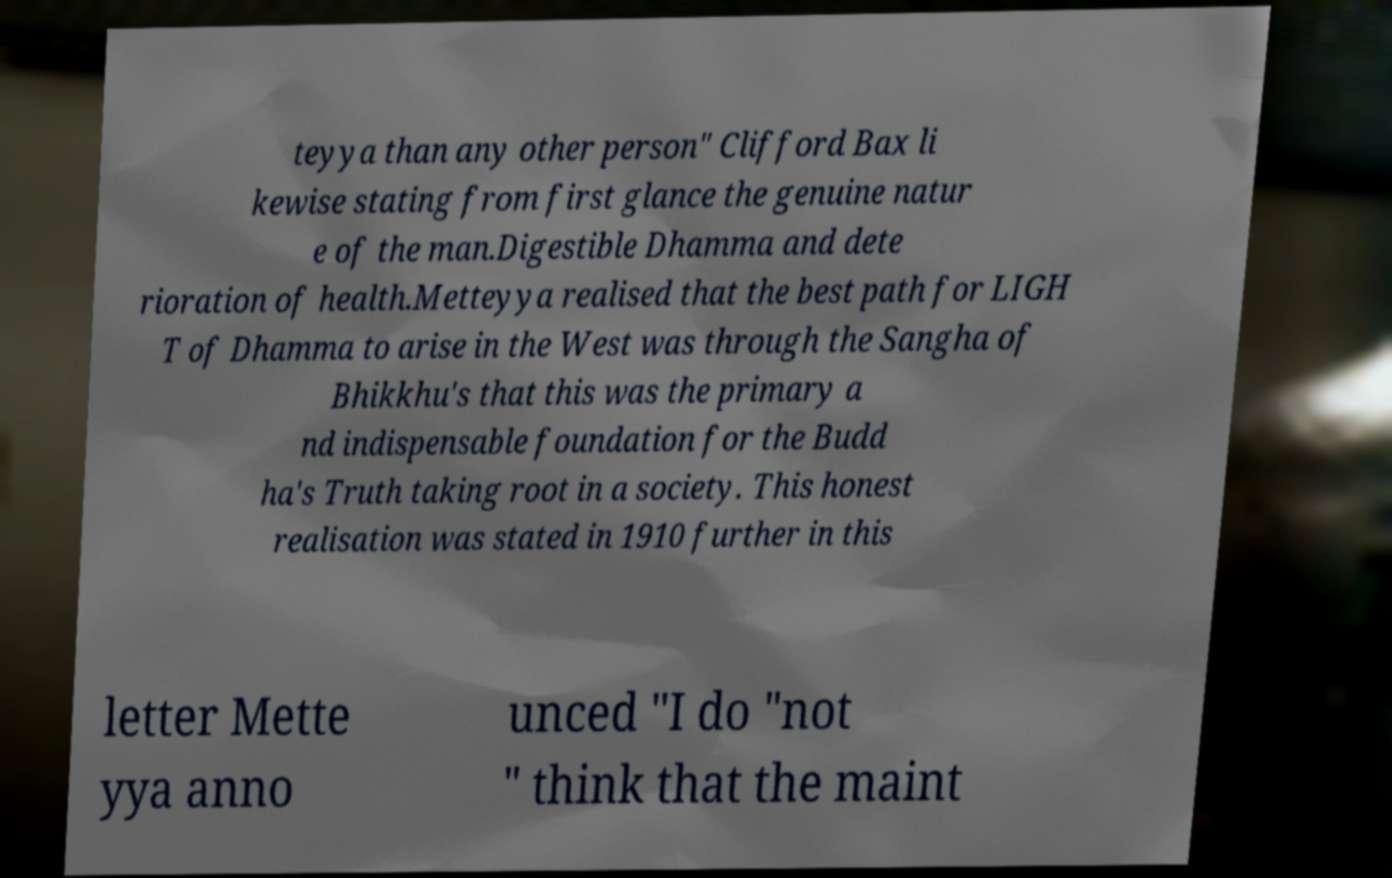Can you read and provide the text displayed in the image?This photo seems to have some interesting text. Can you extract and type it out for me? teyya than any other person" Clifford Bax li kewise stating from first glance the genuine natur e of the man.Digestible Dhamma and dete rioration of health.Metteyya realised that the best path for LIGH T of Dhamma to arise in the West was through the Sangha of Bhikkhu's that this was the primary a nd indispensable foundation for the Budd ha's Truth taking root in a society. This honest realisation was stated in 1910 further in this letter Mette yya anno unced "I do "not " think that the maint 